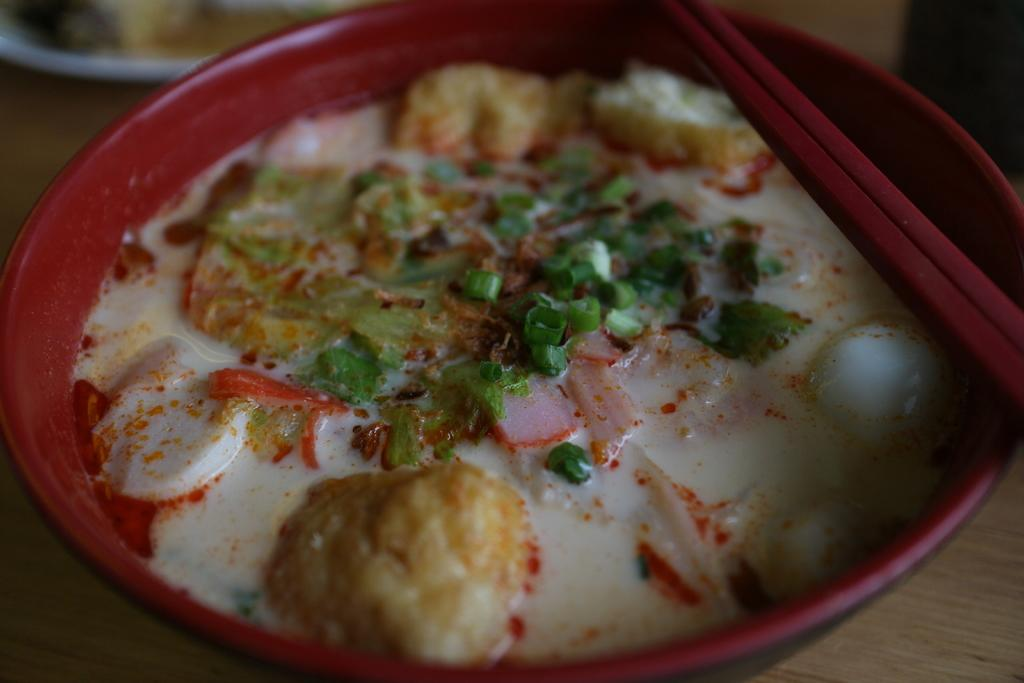What type of food is in the bowl in the image? The facts do not specify the type of food in the bowl. What utensils are present on the table in the image? There are chopsticks on the table in the image. What other dishware can be seen in the image? There is a plate on the side in the image. Is the food in the bowl being used as fuel in the image? No, the food in the bowl is not being used as fuel in the image. Can you see any quicksand in the image? No, there is no quicksand present in the image. 